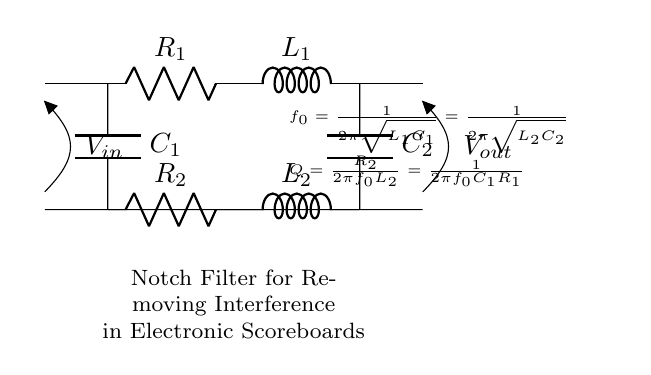What is the type of filter represented in the circuit? This circuit is specifically designed as a notch filter, which is indicated by the title of the diagram. A notch filter is used to eliminate specific frequencies and interfere with signals.
Answer: Notch filter What are the values of the inductors in the circuit? The circuit contains two inductors, L1 and L2. However, their specific values are not provided in the diagram. The general notation indicates that they form part of the notch filter.
Answer: L1, L2 How many resistors are present in the circuit? There are two resistors shown in the circuit diagram, R1 and R2. They are used in conjunction with the inductors and capacitors to form the notch filter function.
Answer: Two What is the formula provided for the center frequency? The circuit provides a formula for the center frequency, expressed as f0 equals one divided by two pi multiplied by the square root of L1 times C1, which is equal to one divided by two pi multiplied by the square root of L2 times C2. This demonstrates the relationship between frequency and circuit components.
Answer: f0 = 1/(2π√(L1C1)) = 1/(2π√(L2C2)) What do the variables R, L, and C represent in this circuit? In the context of this circuit, R represents resistance, L represents inductance, and C represents capacitance. These components are essential in defining the filter characteristics of the notch filter.
Answer: R = resistance, L = inductance, C = capacitance What is the purpose of the capacitor in the circuit? The capacitors C1 and C2 are critical components of the notch filter. They, together with the resistors and inductors, help determine the cutoff frequency where interference is attenuated.
Answer: Attenuate interference What is the voltage at the input and output terminals? The input voltage, denoted as Vin, and the output voltage, denoted as Vout, are both labeled on the circuit diagram. They indicate the potential differences at the respective terminals of the filter.
Answer: Vin, Vout 